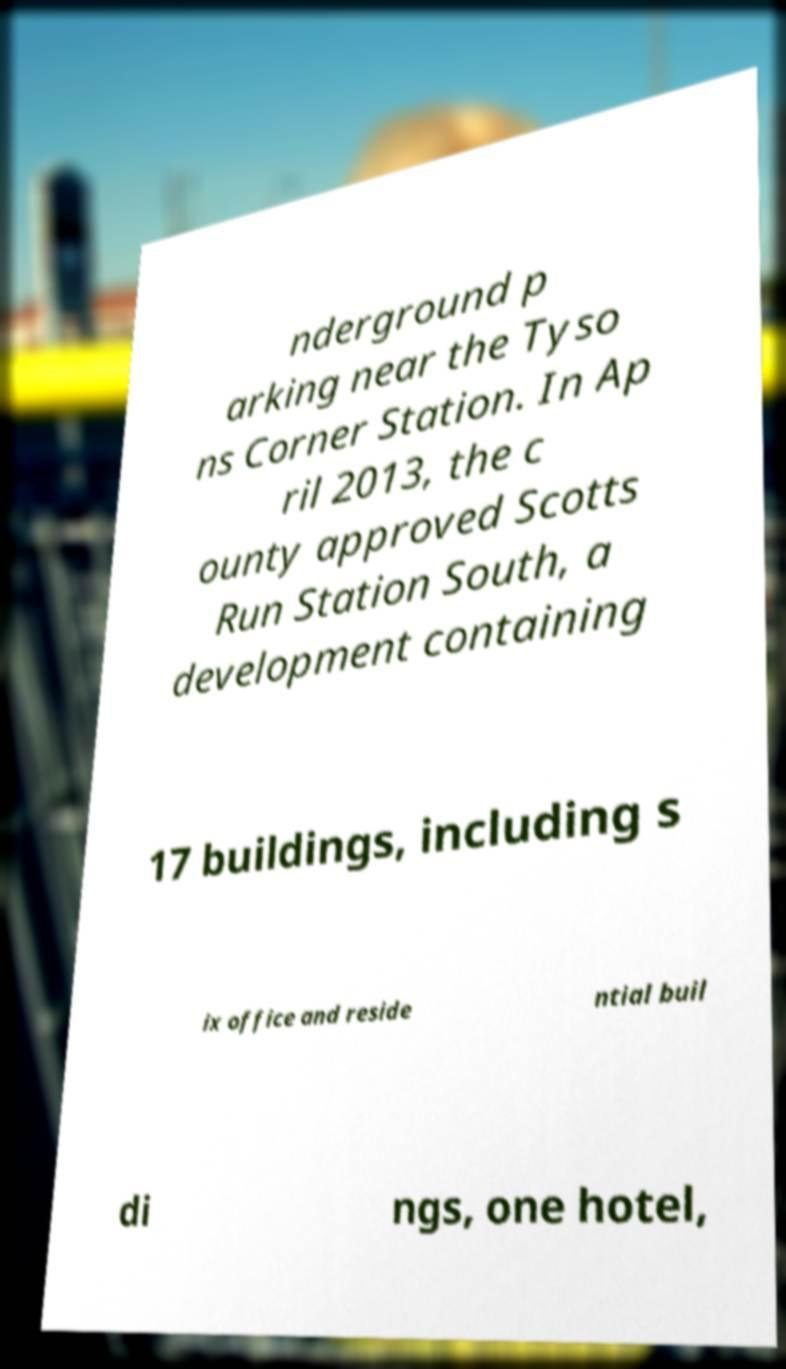I need the written content from this picture converted into text. Can you do that? nderground p arking near the Tyso ns Corner Station. In Ap ril 2013, the c ounty approved Scotts Run Station South, a development containing 17 buildings, including s ix office and reside ntial buil di ngs, one hotel, 